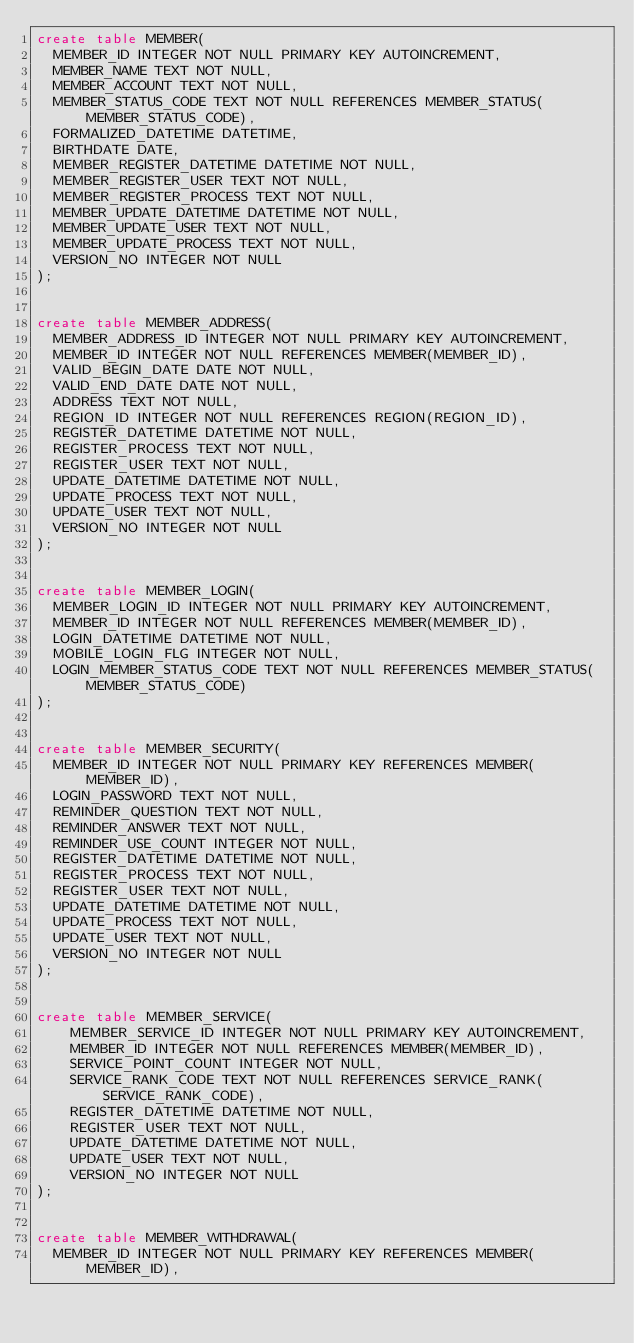<code> <loc_0><loc_0><loc_500><loc_500><_SQL_>create table MEMBER(
	MEMBER_ID INTEGER NOT NULL PRIMARY KEY AUTOINCREMENT,
	MEMBER_NAME TEXT NOT NULL,
	MEMBER_ACCOUNT TEXT NOT NULL,
	MEMBER_STATUS_CODE TEXT NOT NULL REFERENCES MEMBER_STATUS(MEMBER_STATUS_CODE),
	FORMALIZED_DATETIME DATETIME,
	BIRTHDATE DATE,
	MEMBER_REGISTER_DATETIME DATETIME NOT NULL,
	MEMBER_REGISTER_USER TEXT NOT NULL,
	MEMBER_REGISTER_PROCESS TEXT NOT NULL,
	MEMBER_UPDATE_DATETIME DATETIME NOT NULL,
	MEMBER_UPDATE_USER TEXT NOT NULL,
	MEMBER_UPDATE_PROCESS TEXT NOT NULL,
	VERSION_NO INTEGER NOT NULL
);


create table MEMBER_ADDRESS(
	MEMBER_ADDRESS_ID INTEGER NOT NULL PRIMARY KEY AUTOINCREMENT,
	MEMBER_ID INTEGER NOT NULL REFERENCES MEMBER(MEMBER_ID),
	VALID_BEGIN_DATE DATE NOT NULL,
	VALID_END_DATE DATE NOT NULL,
	ADDRESS TEXT NOT NULL,
	REGION_ID INTEGER NOT NULL REFERENCES REGION(REGION_ID),
	REGISTER_DATETIME DATETIME NOT NULL,
	REGISTER_PROCESS TEXT NOT NULL,
	REGISTER_USER TEXT NOT NULL,
	UPDATE_DATETIME DATETIME NOT NULL,
	UPDATE_PROCESS TEXT NOT NULL,
	UPDATE_USER TEXT NOT NULL,
	VERSION_NO INTEGER NOT NULL
);


create table MEMBER_LOGIN(
	MEMBER_LOGIN_ID INTEGER NOT NULL PRIMARY KEY AUTOINCREMENT,
	MEMBER_ID INTEGER NOT NULL REFERENCES MEMBER(MEMBER_ID),
	LOGIN_DATETIME DATETIME NOT NULL,
	MOBILE_LOGIN_FLG INTEGER NOT NULL,
	LOGIN_MEMBER_STATUS_CODE TEXT NOT NULL REFERENCES MEMBER_STATUS(MEMBER_STATUS_CODE)
);


create table MEMBER_SECURITY(
	MEMBER_ID INTEGER NOT NULL PRIMARY KEY REFERENCES MEMBER(MEMBER_ID),
	LOGIN_PASSWORD TEXT NOT NULL,
	REMINDER_QUESTION TEXT NOT NULL,
	REMINDER_ANSWER TEXT NOT NULL,
	REMINDER_USE_COUNT INTEGER NOT NULL,
	REGISTER_DATETIME DATETIME NOT NULL,
	REGISTER_PROCESS TEXT NOT NULL,
	REGISTER_USER TEXT NOT NULL,
	UPDATE_DATETIME DATETIME NOT NULL,
	UPDATE_PROCESS TEXT NOT NULL,
	UPDATE_USER TEXT NOT NULL,
	VERSION_NO INTEGER NOT NULL
);


create table MEMBER_SERVICE(
    MEMBER_SERVICE_ID INTEGER NOT NULL PRIMARY KEY AUTOINCREMENT,
    MEMBER_ID INTEGER NOT NULL REFERENCES MEMBER(MEMBER_ID),
    SERVICE_POINT_COUNT INTEGER NOT NULL,
    SERVICE_RANK_CODE TEXT NOT NULL REFERENCES SERVICE_RANK(SERVICE_RANK_CODE),
    REGISTER_DATETIME DATETIME NOT NULL,
    REGISTER_USER TEXT NOT NULL,
    UPDATE_DATETIME DATETIME NOT NULL,
    UPDATE_USER TEXT NOT NULL,
    VERSION_NO INTEGER NOT NULL
);


create table MEMBER_WITHDRAWAL(
	MEMBER_ID INTEGER NOT NULL PRIMARY KEY REFERENCES MEMBER(MEMBER_ID),</code> 